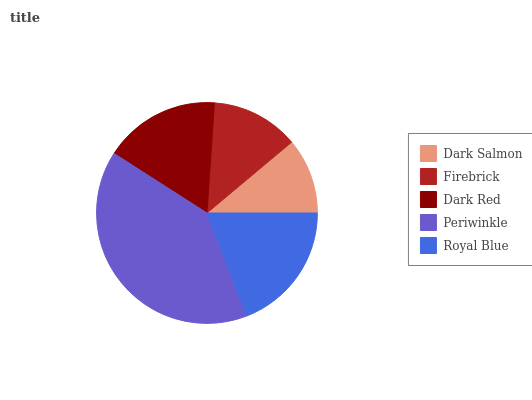Is Dark Salmon the minimum?
Answer yes or no. Yes. Is Periwinkle the maximum?
Answer yes or no. Yes. Is Firebrick the minimum?
Answer yes or no. No. Is Firebrick the maximum?
Answer yes or no. No. Is Firebrick greater than Dark Salmon?
Answer yes or no. Yes. Is Dark Salmon less than Firebrick?
Answer yes or no. Yes. Is Dark Salmon greater than Firebrick?
Answer yes or no. No. Is Firebrick less than Dark Salmon?
Answer yes or no. No. Is Dark Red the high median?
Answer yes or no. Yes. Is Dark Red the low median?
Answer yes or no. Yes. Is Royal Blue the high median?
Answer yes or no. No. Is Dark Salmon the low median?
Answer yes or no. No. 